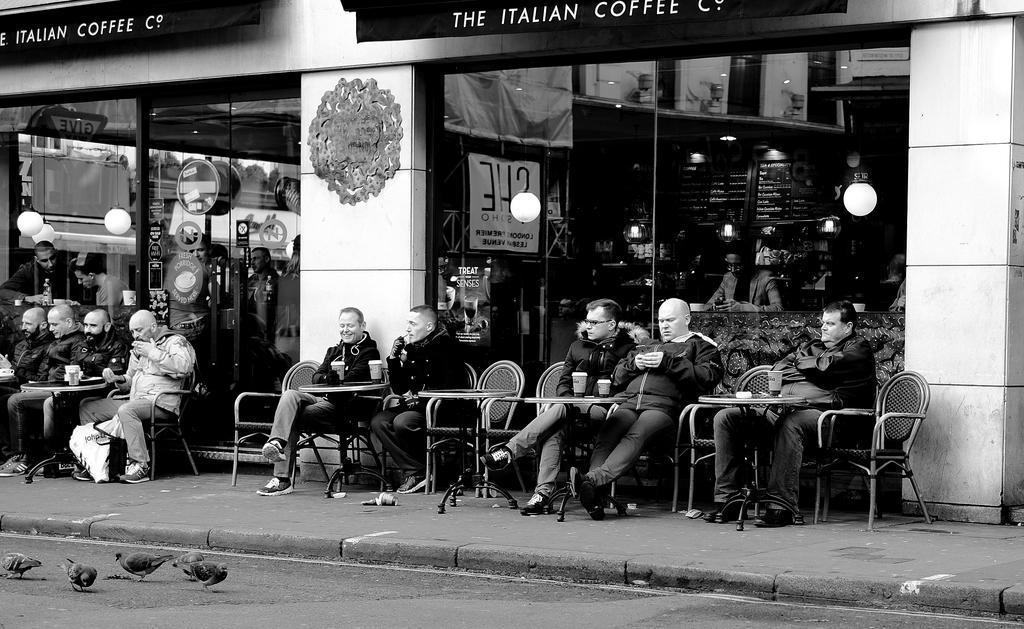Can you describe this image briefly? In this image in the center there are a group of people who are sitting on chairs, and they are holding cups and drinking and some of them are holding mobiles and some other things. And at the bottom there is a walkway, and some boards. And in the background there is a building and there are glass windows, through the windows we could see some boards and buildings and some objects. And at the top of the building there are boards. 